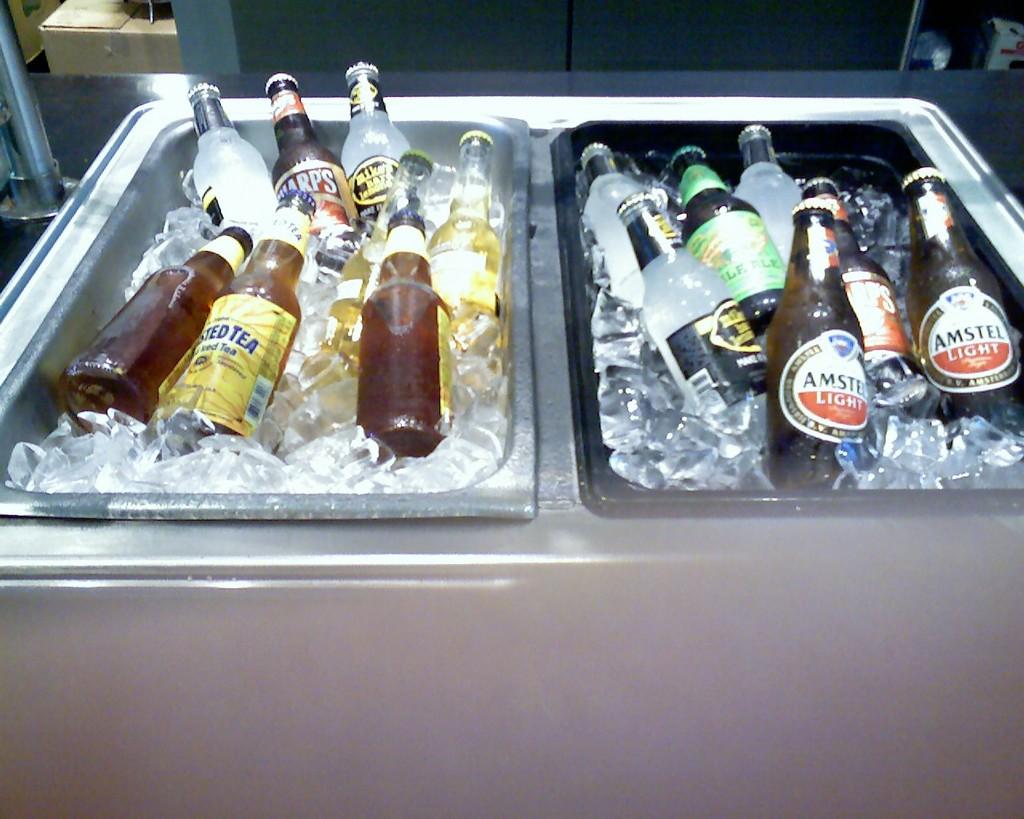What brand of beer is in the brown bottle on the right?
Your response must be concise. Amstel light. What type of beverage is in the brown bottle on the right?
Offer a very short reply. Amstel light. 